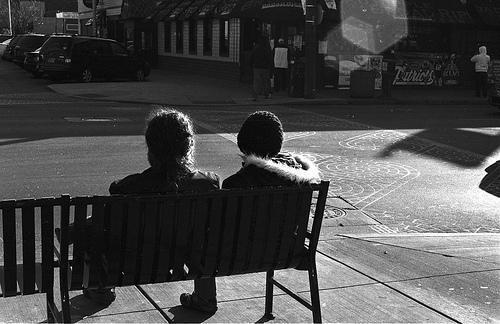How many people are on the bench?
Give a very brief answer. 2. 